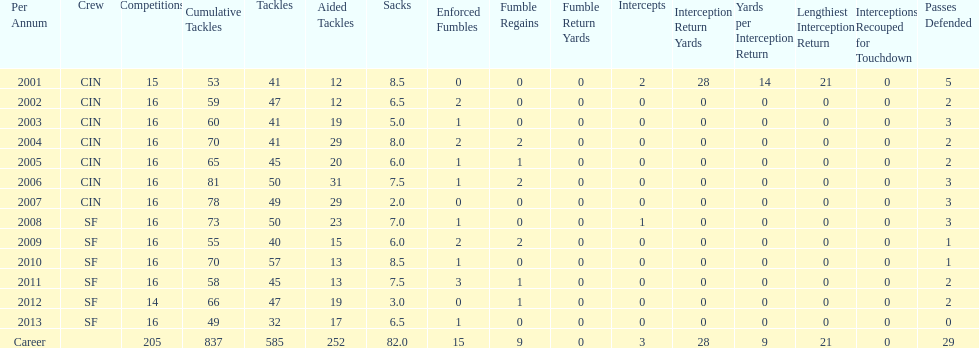How many consecutive seasons has he played sixteen games? 10. 